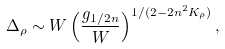Convert formula to latex. <formula><loc_0><loc_0><loc_500><loc_500>\Delta _ { \rho } \sim W \left ( \frac { g _ { 1 / 2 n } } { W } \right ) ^ { 1 / ( 2 - 2 n ^ { 2 } K _ { \rho } ) } ,</formula> 